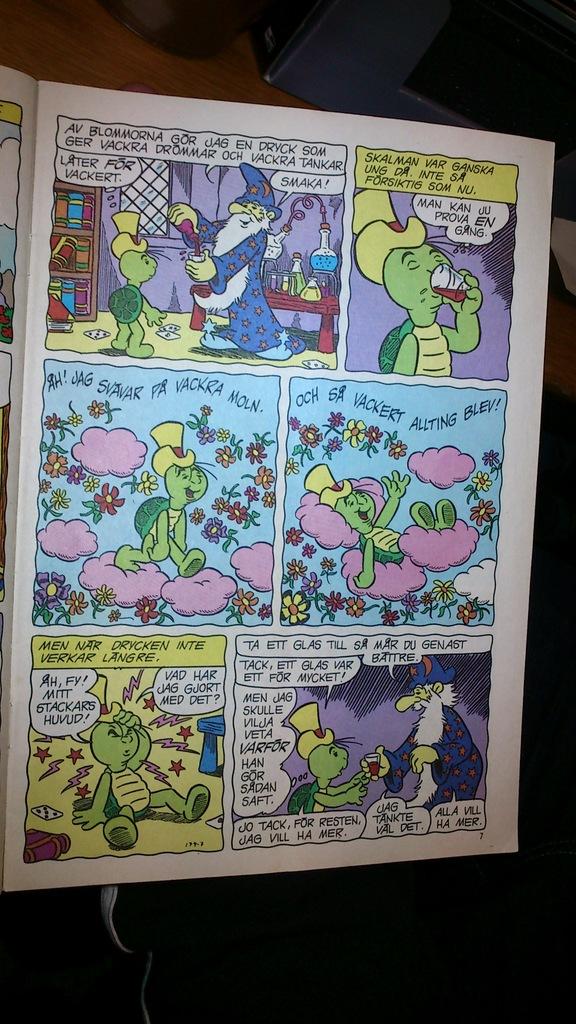What first two letters are in the beginning of this comic?
Provide a succinct answer. Av. 